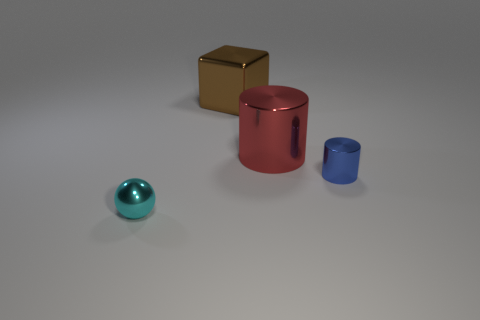Add 1 large cylinders. How many objects exist? 5 Subtract all red cylinders. How many cylinders are left? 1 Add 2 metal cylinders. How many metal cylinders exist? 4 Subtract 1 brown blocks. How many objects are left? 3 Subtract all balls. How many objects are left? 3 Subtract all purple cylinders. Subtract all purple balls. How many cylinders are left? 2 Subtract all big gray matte things. Subtract all brown metal cubes. How many objects are left? 3 Add 1 red shiny things. How many red shiny things are left? 2 